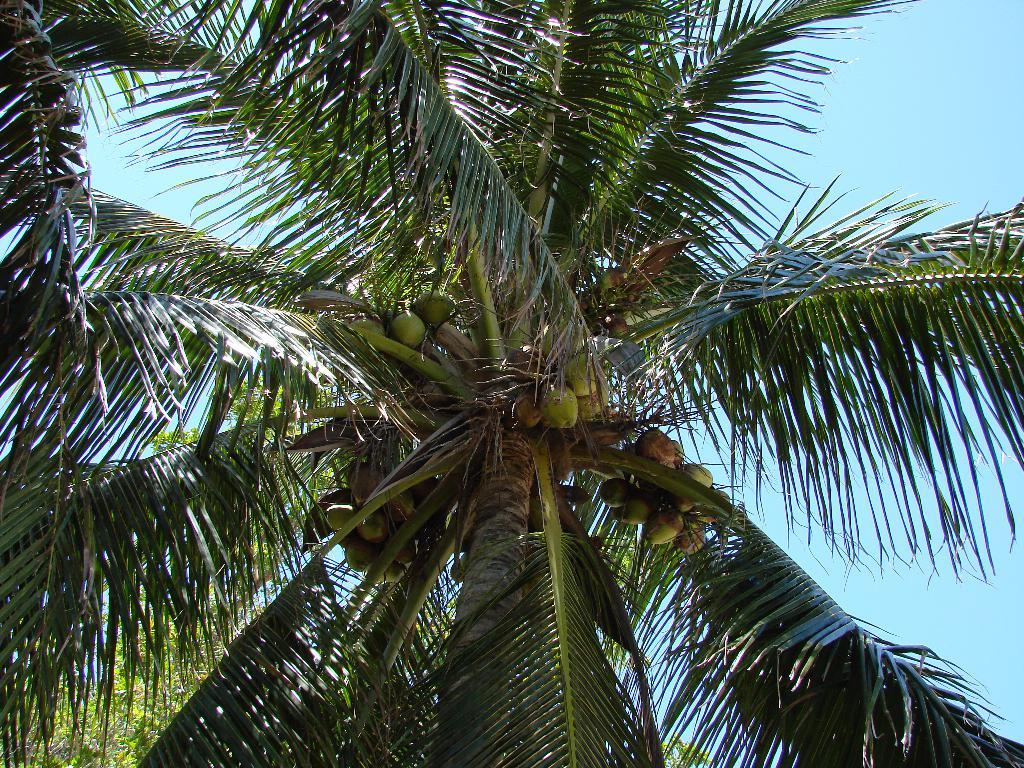What type of trees are present in the image? There are coconut trees in the image. Are there any coconuts on the trees? Yes, there are coconuts on the trees. What can be seen in the background of the image? The sky is visible in the image. How many bubbles can be seen floating near the coconut trees in the image? There are no bubbles present in the image; it features coconut trees and coconuts. 